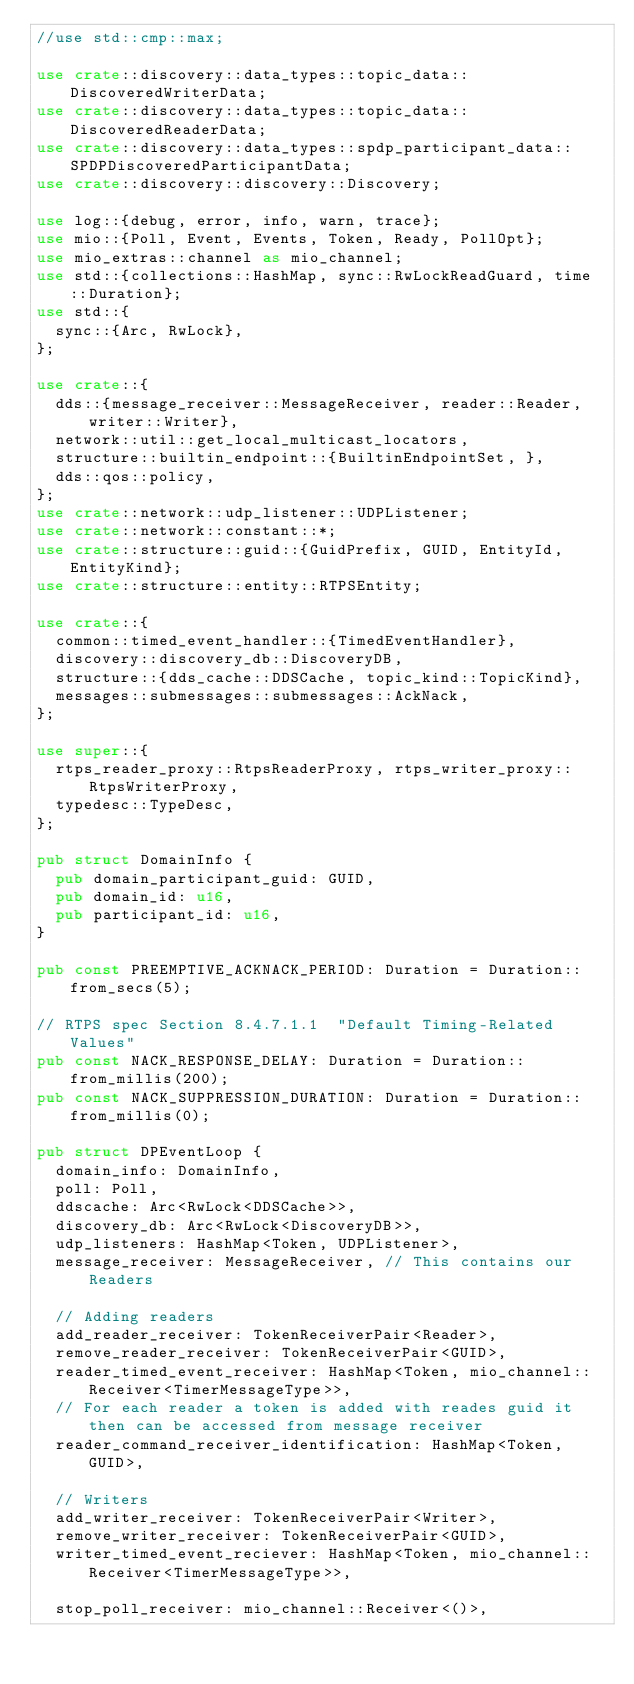Convert code to text. <code><loc_0><loc_0><loc_500><loc_500><_Rust_>//use std::cmp::max;

use crate::discovery::data_types::topic_data::DiscoveredWriterData;
use crate::discovery::data_types::topic_data::DiscoveredReaderData;
use crate::discovery::data_types::spdp_participant_data::SPDPDiscoveredParticipantData;
use crate::discovery::discovery::Discovery;

use log::{debug, error, info, warn, trace};
use mio::{Poll, Event, Events, Token, Ready, PollOpt};
use mio_extras::channel as mio_channel;
use std::{collections::HashMap, sync::RwLockReadGuard, time::Duration};
use std::{
  sync::{Arc, RwLock},
};

use crate::{
  dds::{message_receiver::MessageReceiver, reader::Reader, writer::Writer},
  network::util::get_local_multicast_locators,
  structure::builtin_endpoint::{BuiltinEndpointSet, },
  dds::qos::policy,
};
use crate::network::udp_listener::UDPListener;
use crate::network::constant::*;
use crate::structure::guid::{GuidPrefix, GUID, EntityId, EntityKind};
use crate::structure::entity::RTPSEntity;

use crate::{
  common::timed_event_handler::{TimedEventHandler},
  discovery::discovery_db::DiscoveryDB,
  structure::{dds_cache::DDSCache, topic_kind::TopicKind},
  messages::submessages::submessages::AckNack,
};

use super::{
  rtps_reader_proxy::RtpsReaderProxy, rtps_writer_proxy::RtpsWriterProxy,
  typedesc::TypeDesc,
};

pub struct DomainInfo {
  pub domain_participant_guid: GUID,
  pub domain_id: u16,
  pub participant_id: u16,
}

pub const PREEMPTIVE_ACKNACK_PERIOD: Duration = Duration::from_secs(5);

// RTPS spec Section 8.4.7.1.1  "Default Timing-Related Values"
pub const NACK_RESPONSE_DELAY: Duration = Duration::from_millis(200); 
pub const NACK_SUPPRESSION_DURATION: Duration = Duration::from_millis(0); 
 
pub struct DPEventLoop {
  domain_info: DomainInfo,
  poll: Poll,
  ddscache: Arc<RwLock<DDSCache>>,
  discovery_db: Arc<RwLock<DiscoveryDB>>,
  udp_listeners: HashMap<Token, UDPListener>,
  message_receiver: MessageReceiver, // This contains our Readers

  // Adding readers
  add_reader_receiver: TokenReceiverPair<Reader>,
  remove_reader_receiver: TokenReceiverPair<GUID>,
  reader_timed_event_receiver: HashMap<Token, mio_channel::Receiver<TimerMessageType>>,
  // For each reader a token is added with reades guid it then can be accessed from message receiver
  reader_command_receiver_identification: HashMap<Token, GUID>,

  // Writers
  add_writer_receiver: TokenReceiverPair<Writer>,
  remove_writer_receiver: TokenReceiverPair<GUID>,
  writer_timed_event_reciever: HashMap<Token, mio_channel::Receiver<TimerMessageType>>,

  stop_poll_receiver: mio_channel::Receiver<()>,</code> 